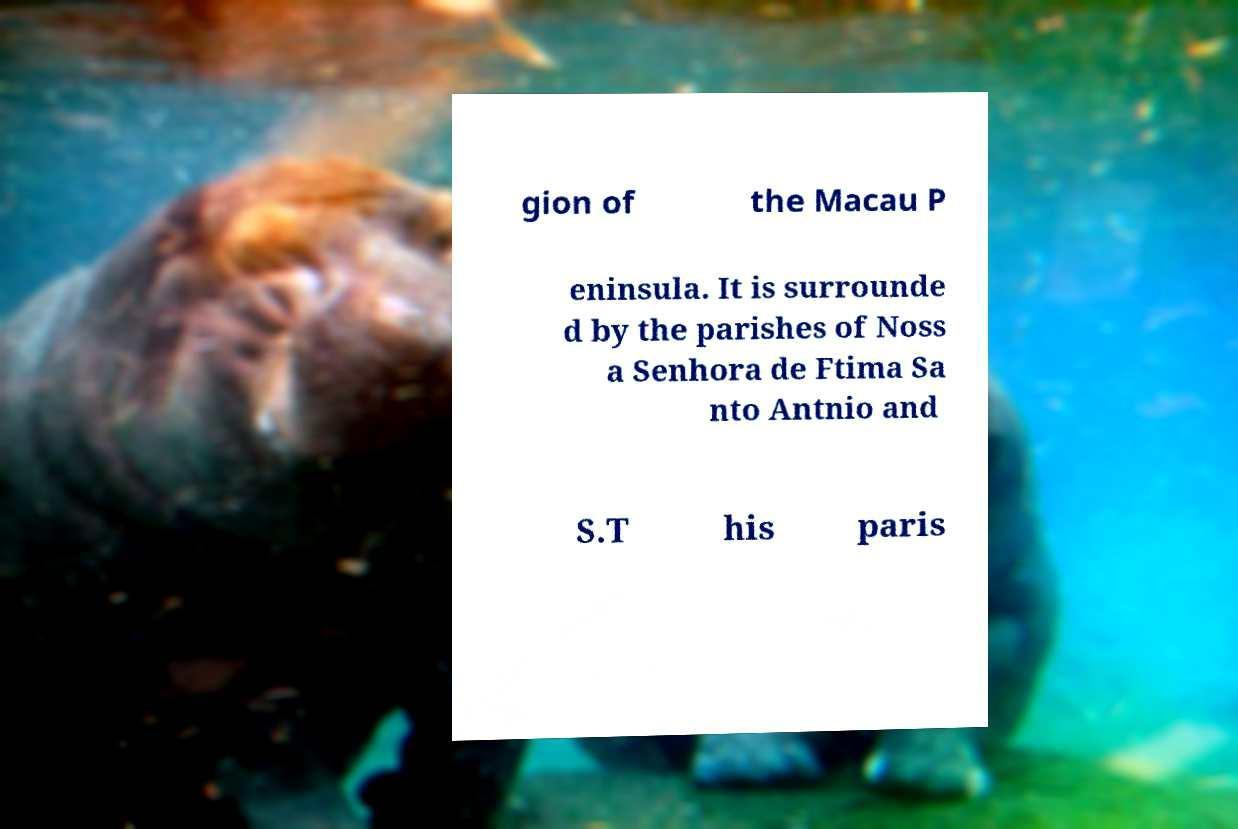There's text embedded in this image that I need extracted. Can you transcribe it verbatim? gion of the Macau P eninsula. It is surrounde d by the parishes of Noss a Senhora de Ftima Sa nto Antnio and S.T his paris 